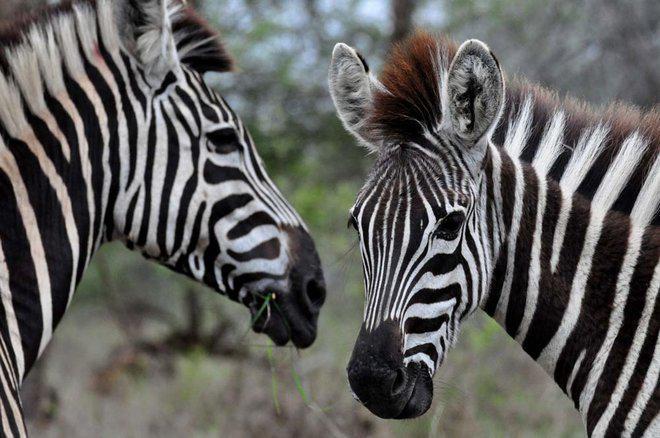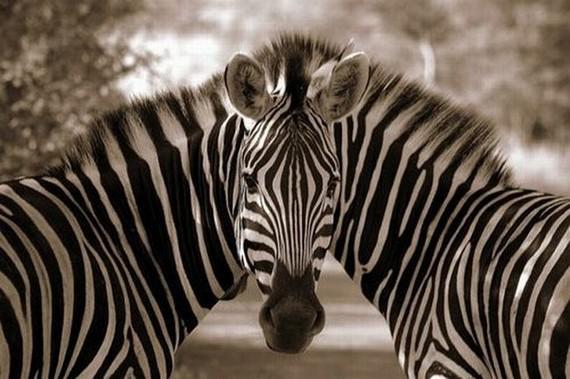The first image is the image on the left, the second image is the image on the right. For the images displayed, is the sentence "One image contains exactly two zebras facing opposite directions with heads that do not overlap, and the other image features one prominent zebra standing with its head upright." factually correct? Answer yes or no. No. The first image is the image on the left, the second image is the image on the right. Analyze the images presented: Is the assertion "There are two zebras and blue sky visible in the left image." valid? Answer yes or no. Yes. 